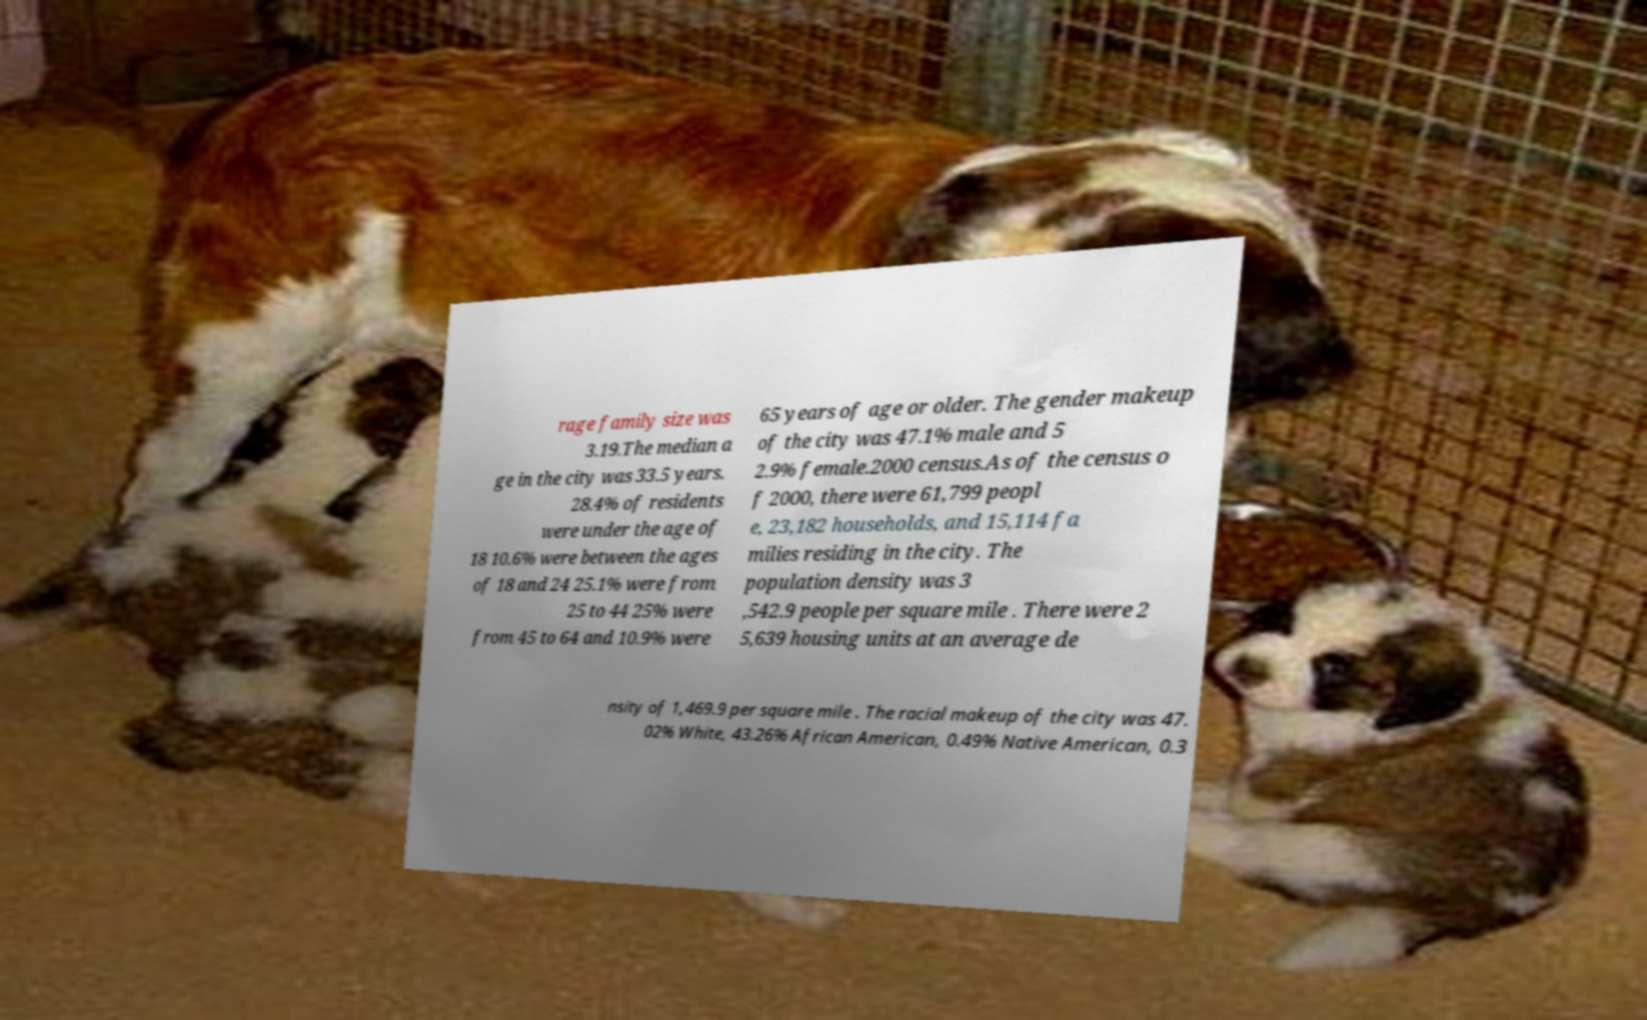For documentation purposes, I need the text within this image transcribed. Could you provide that? rage family size was 3.19.The median a ge in the city was 33.5 years. 28.4% of residents were under the age of 18 10.6% were between the ages of 18 and 24 25.1% were from 25 to 44 25% were from 45 to 64 and 10.9% were 65 years of age or older. The gender makeup of the city was 47.1% male and 5 2.9% female.2000 census.As of the census o f 2000, there were 61,799 peopl e, 23,182 households, and 15,114 fa milies residing in the city. The population density was 3 ,542.9 people per square mile . There were 2 5,639 housing units at an average de nsity of 1,469.9 per square mile . The racial makeup of the city was 47. 02% White, 43.26% African American, 0.49% Native American, 0.3 